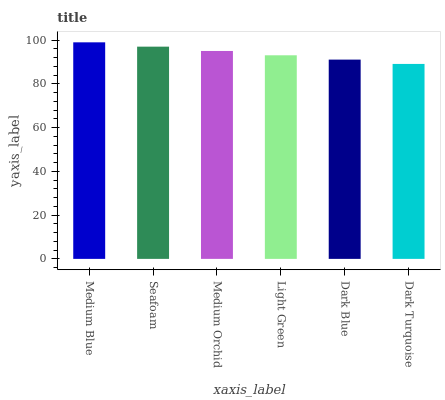Is Dark Turquoise the minimum?
Answer yes or no. Yes. Is Medium Blue the maximum?
Answer yes or no. Yes. Is Seafoam the minimum?
Answer yes or no. No. Is Seafoam the maximum?
Answer yes or no. No. Is Medium Blue greater than Seafoam?
Answer yes or no. Yes. Is Seafoam less than Medium Blue?
Answer yes or no. Yes. Is Seafoam greater than Medium Blue?
Answer yes or no. No. Is Medium Blue less than Seafoam?
Answer yes or no. No. Is Medium Orchid the high median?
Answer yes or no. Yes. Is Light Green the low median?
Answer yes or no. Yes. Is Light Green the high median?
Answer yes or no. No. Is Medium Orchid the low median?
Answer yes or no. No. 